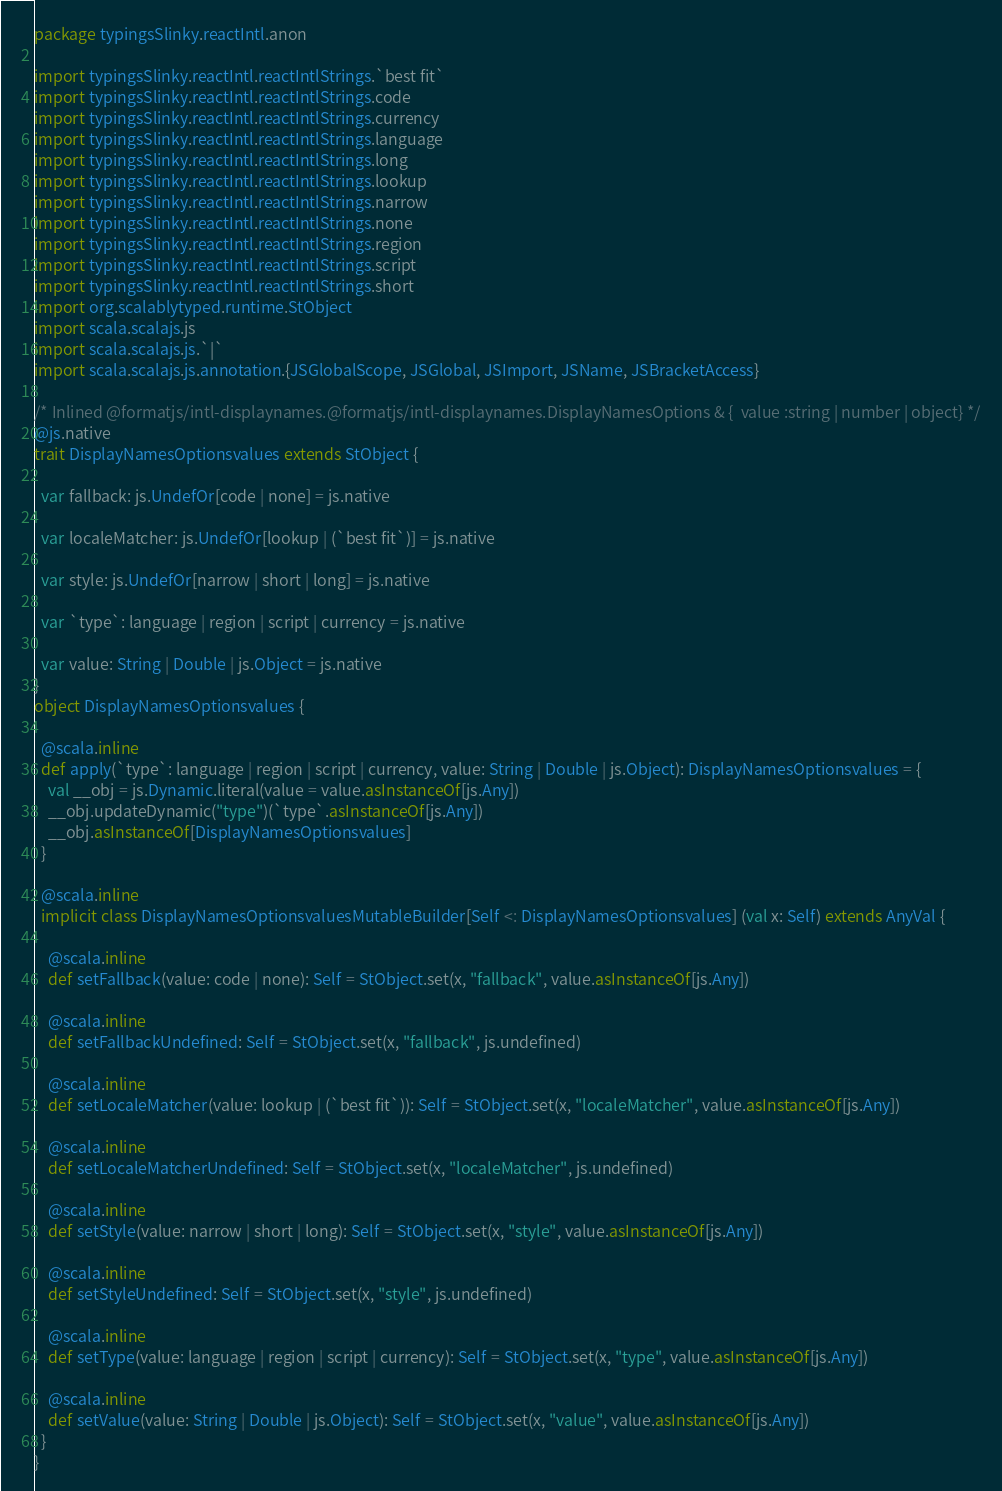Convert code to text. <code><loc_0><loc_0><loc_500><loc_500><_Scala_>package typingsSlinky.reactIntl.anon

import typingsSlinky.reactIntl.reactIntlStrings.`best fit`
import typingsSlinky.reactIntl.reactIntlStrings.code
import typingsSlinky.reactIntl.reactIntlStrings.currency
import typingsSlinky.reactIntl.reactIntlStrings.language
import typingsSlinky.reactIntl.reactIntlStrings.long
import typingsSlinky.reactIntl.reactIntlStrings.lookup
import typingsSlinky.reactIntl.reactIntlStrings.narrow
import typingsSlinky.reactIntl.reactIntlStrings.none
import typingsSlinky.reactIntl.reactIntlStrings.region
import typingsSlinky.reactIntl.reactIntlStrings.script
import typingsSlinky.reactIntl.reactIntlStrings.short
import org.scalablytyped.runtime.StObject
import scala.scalajs.js
import scala.scalajs.js.`|`
import scala.scalajs.js.annotation.{JSGlobalScope, JSGlobal, JSImport, JSName, JSBracketAccess}

/* Inlined @formatjs/intl-displaynames.@formatjs/intl-displaynames.DisplayNamesOptions & {  value :string | number | object} */
@js.native
trait DisplayNamesOptionsvalues extends StObject {
  
  var fallback: js.UndefOr[code | none] = js.native
  
  var localeMatcher: js.UndefOr[lookup | (`best fit`)] = js.native
  
  var style: js.UndefOr[narrow | short | long] = js.native
  
  var `type`: language | region | script | currency = js.native
  
  var value: String | Double | js.Object = js.native
}
object DisplayNamesOptionsvalues {
  
  @scala.inline
  def apply(`type`: language | region | script | currency, value: String | Double | js.Object): DisplayNamesOptionsvalues = {
    val __obj = js.Dynamic.literal(value = value.asInstanceOf[js.Any])
    __obj.updateDynamic("type")(`type`.asInstanceOf[js.Any])
    __obj.asInstanceOf[DisplayNamesOptionsvalues]
  }
  
  @scala.inline
  implicit class DisplayNamesOptionsvaluesMutableBuilder[Self <: DisplayNamesOptionsvalues] (val x: Self) extends AnyVal {
    
    @scala.inline
    def setFallback(value: code | none): Self = StObject.set(x, "fallback", value.asInstanceOf[js.Any])
    
    @scala.inline
    def setFallbackUndefined: Self = StObject.set(x, "fallback", js.undefined)
    
    @scala.inline
    def setLocaleMatcher(value: lookup | (`best fit`)): Self = StObject.set(x, "localeMatcher", value.asInstanceOf[js.Any])
    
    @scala.inline
    def setLocaleMatcherUndefined: Self = StObject.set(x, "localeMatcher", js.undefined)
    
    @scala.inline
    def setStyle(value: narrow | short | long): Self = StObject.set(x, "style", value.asInstanceOf[js.Any])
    
    @scala.inline
    def setStyleUndefined: Self = StObject.set(x, "style", js.undefined)
    
    @scala.inline
    def setType(value: language | region | script | currency): Self = StObject.set(x, "type", value.asInstanceOf[js.Any])
    
    @scala.inline
    def setValue(value: String | Double | js.Object): Self = StObject.set(x, "value", value.asInstanceOf[js.Any])
  }
}
</code> 